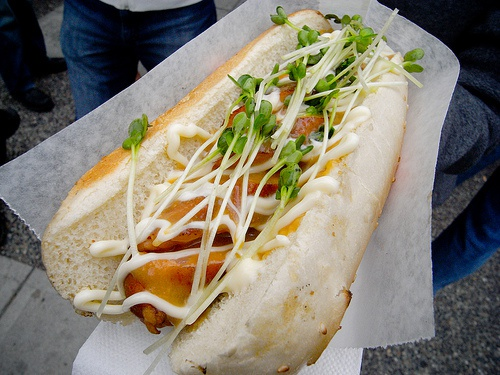Describe the objects in this image and their specific colors. I can see hot dog in black, lightgray, tan, and darkgray tones and people in black, navy, gray, and blue tones in this image. 